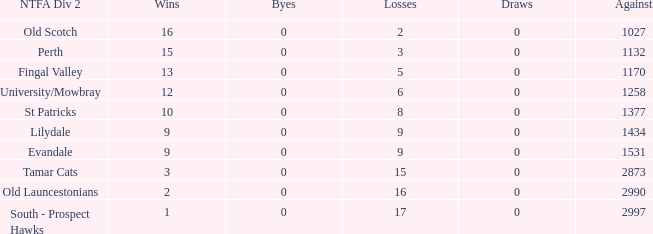What is the lowest number of draws of the team with 9 wins and less than 0 byes? None. 